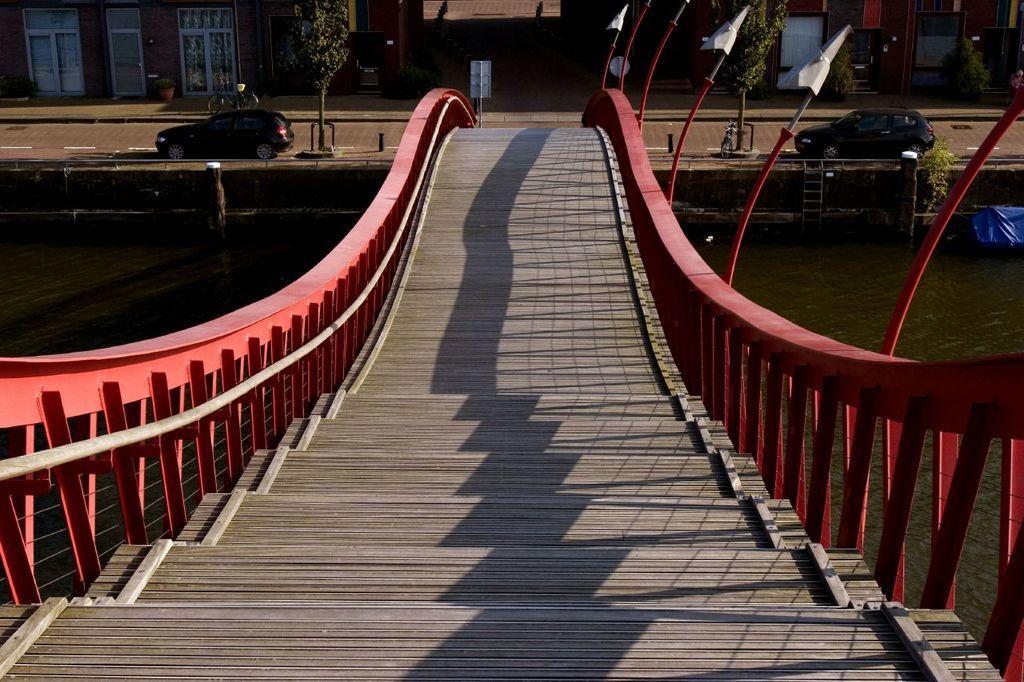Describe this image in one or two sentences. In this image I can see the bridge and the railing. On both sides of the bridge I can see the water. In the background I can see the vehicles on the road. I can see the poles, boards, trees and the buildings. 